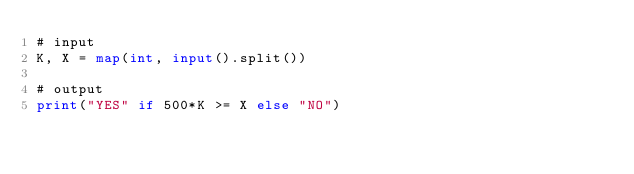Convert code to text. <code><loc_0><loc_0><loc_500><loc_500><_Python_># input
K, X = map(int, input().split())

# output
print("YES" if 500*K >= X else "NO")
</code> 